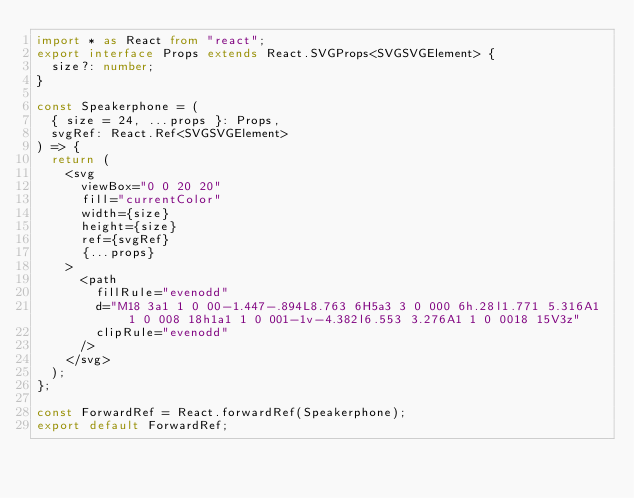<code> <loc_0><loc_0><loc_500><loc_500><_TypeScript_>import * as React from "react";
export interface Props extends React.SVGProps<SVGSVGElement> {
  size?: number;
}

const Speakerphone = (
  { size = 24, ...props }: Props,
  svgRef: React.Ref<SVGSVGElement>
) => {
  return (
    <svg
      viewBox="0 0 20 20"
      fill="currentColor"
      width={size}
      height={size}
      ref={svgRef}
      {...props}
    >
      <path
        fillRule="evenodd"
        d="M18 3a1 1 0 00-1.447-.894L8.763 6H5a3 3 0 000 6h.28l1.771 5.316A1 1 0 008 18h1a1 1 0 001-1v-4.382l6.553 3.276A1 1 0 0018 15V3z"
        clipRule="evenodd"
      />
    </svg>
  );
};

const ForwardRef = React.forwardRef(Speakerphone);
export default ForwardRef;
</code> 